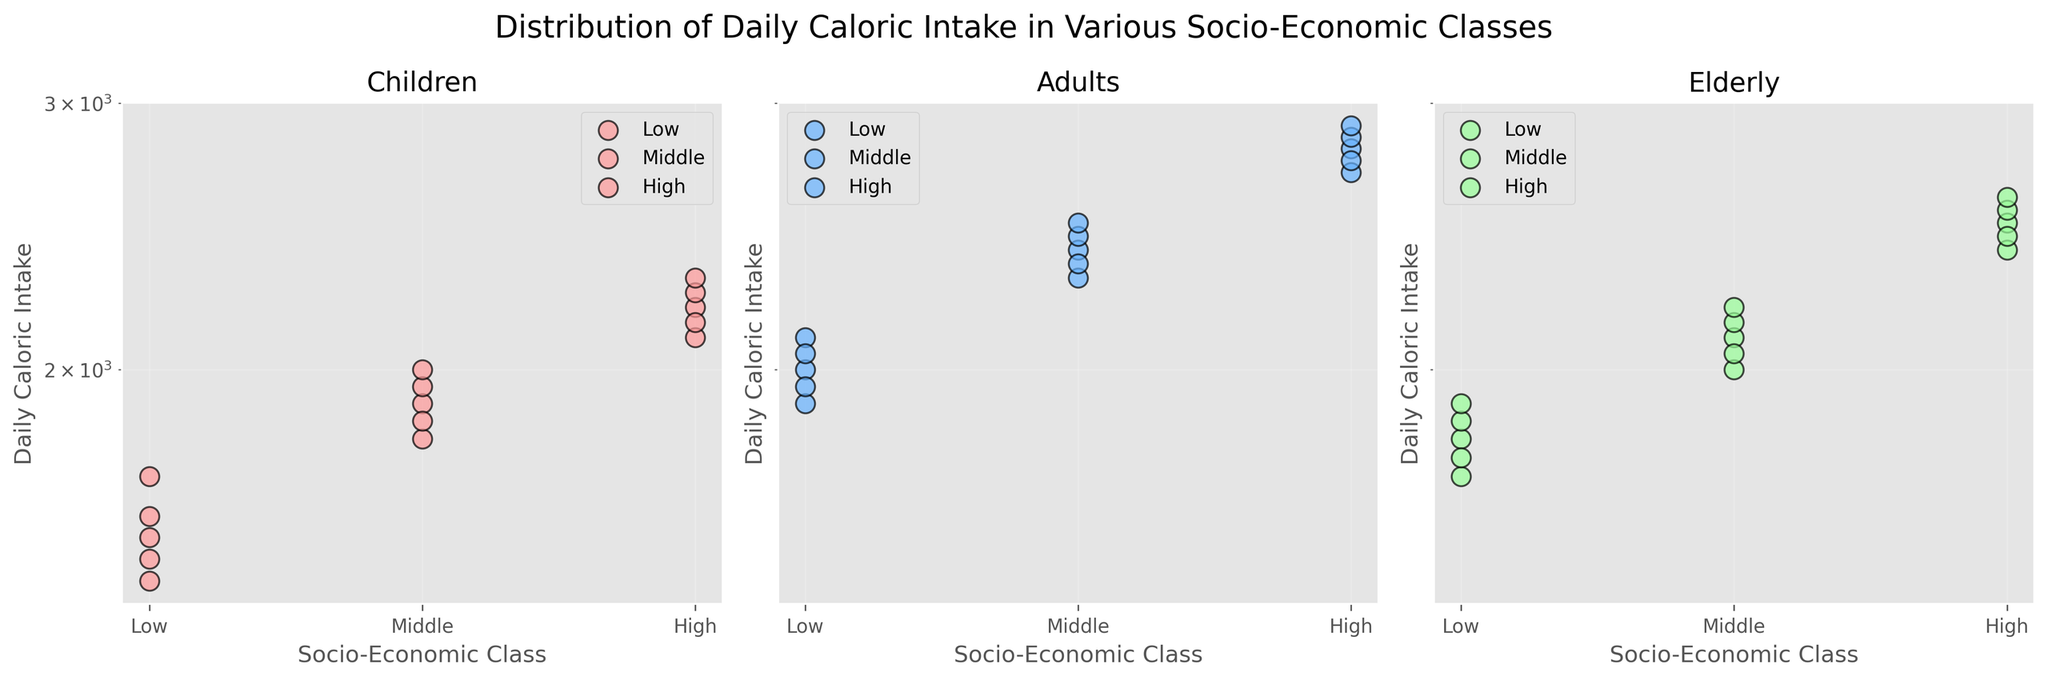What's the title of the figure? The title is the first visual element you encounter at the top of the figure. It summarizes the content of the plot, providing context for the data presented within.
Answer: Distribution of Daily Caloric Intake in Various Socio-Economic Classes How many subplots are there in the figure? The figure is divided vertically or horizontally. The title box often indicates how many distinct areas the figure contains.
Answer: 3 What are the age groups included in the subplots? Each subplot represents a different age group. The headings of these subplots specify this information.
Answer: Children, Adults, Elderly Which Socio-Economic Class has the highest Daily Caloric Intake for 'Children'? Observing the plot for 'Children', compare the position of the data points. The class with the highest vertical position (caloric intake) has the highest value.
Answer: High In the subplot for Adults, which Socio-Economic Class has the lowest Daily Caloric Intake? Focus on the 'Adults' subplot. Identify the position of data points and look at the class with the lowest vertical marker.
Answer: Low Which Age Group has the highest average Daily Caloric Intake in the 'Middle' class? Examine the middle-class points in all subplots, calculate (or visually estimate) the average vertical position within each plot. Compare these averages across the three age groups.
Answer: Adults What is the color used for the 'Elderly' group in the plot? Each subplot (age group) is assigned a unique color. Look at the Elderly subplot to determine the color it uses.
Answer: Green Is the log scale affecting how you perceive the differences between the Socio-Economic Classes? A log scale reduces the visual difference between smaller and larger values, making variations in lower values more prominent visually.
Answer: Yes Which age group shows the most variance in Daily Caloric Intake for the 'High' Socio-Economic Class? Variance can be interpreted by observing the spread of vertical data points for the 'High' class in each age group subplot. The wider the spread, the higher the variance.
Answer: Adults Comparing the 'Children' and 'Elderly' groups, which socio-economic class shows the largest absolute difference in caloric intake? Look at the extreme values for both 'Children' and 'Elderly' groups within each socio-economic class. Subtract the caloric intake of the highest Elderly point from the highest Children point, and repeat for all classes to find which class has the largest difference.
Answer: High 